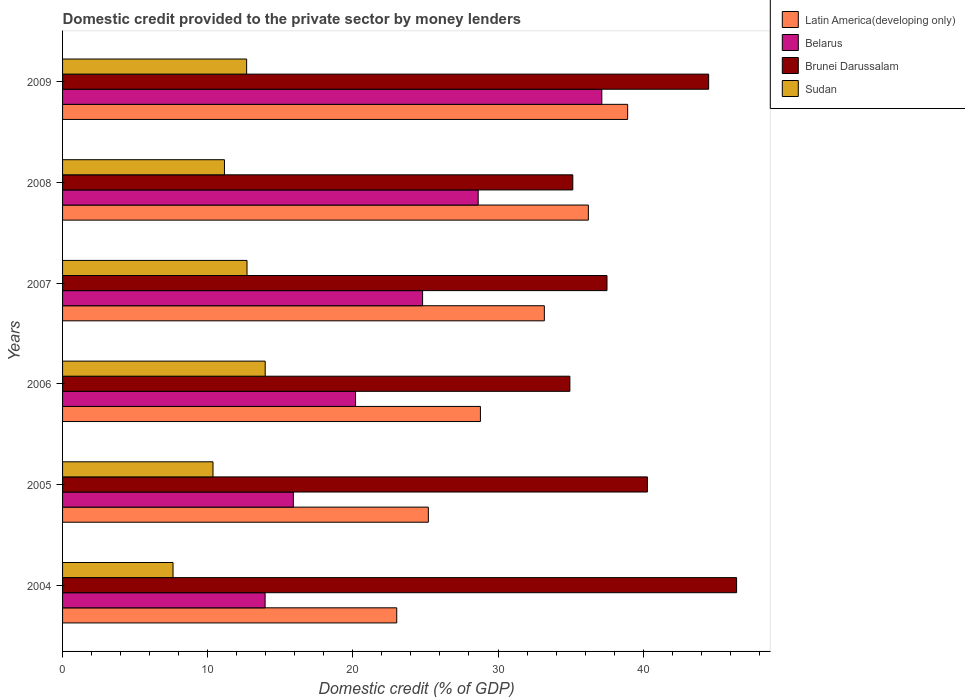Are the number of bars per tick equal to the number of legend labels?
Keep it short and to the point. Yes. What is the domestic credit provided to the private sector by money lenders in Brunei Darussalam in 2005?
Offer a very short reply. 40.29. Across all years, what is the maximum domestic credit provided to the private sector by money lenders in Belarus?
Ensure brevity in your answer.  37.15. Across all years, what is the minimum domestic credit provided to the private sector by money lenders in Belarus?
Your response must be concise. 13.95. In which year was the domestic credit provided to the private sector by money lenders in Sudan minimum?
Provide a succinct answer. 2004. What is the total domestic credit provided to the private sector by money lenders in Sudan in the graph?
Offer a terse response. 68.48. What is the difference between the domestic credit provided to the private sector by money lenders in Brunei Darussalam in 2006 and that in 2007?
Provide a succinct answer. -2.56. What is the difference between the domestic credit provided to the private sector by money lenders in Brunei Darussalam in 2005 and the domestic credit provided to the private sector by money lenders in Sudan in 2007?
Offer a terse response. 27.58. What is the average domestic credit provided to the private sector by money lenders in Latin America(developing only) per year?
Make the answer very short. 30.89. In the year 2005, what is the difference between the domestic credit provided to the private sector by money lenders in Brunei Darussalam and domestic credit provided to the private sector by money lenders in Belarus?
Give a very brief answer. 24.39. In how many years, is the domestic credit provided to the private sector by money lenders in Latin America(developing only) greater than 30 %?
Make the answer very short. 3. What is the ratio of the domestic credit provided to the private sector by money lenders in Belarus in 2004 to that in 2005?
Ensure brevity in your answer.  0.88. Is the difference between the domestic credit provided to the private sector by money lenders in Brunei Darussalam in 2006 and 2009 greater than the difference between the domestic credit provided to the private sector by money lenders in Belarus in 2006 and 2009?
Your answer should be compact. Yes. What is the difference between the highest and the second highest domestic credit provided to the private sector by money lenders in Belarus?
Keep it short and to the point. 8.52. What is the difference between the highest and the lowest domestic credit provided to the private sector by money lenders in Latin America(developing only)?
Your answer should be compact. 15.91. Is the sum of the domestic credit provided to the private sector by money lenders in Brunei Darussalam in 2004 and 2007 greater than the maximum domestic credit provided to the private sector by money lenders in Latin America(developing only) across all years?
Offer a terse response. Yes. What does the 1st bar from the top in 2009 represents?
Ensure brevity in your answer.  Sudan. What does the 2nd bar from the bottom in 2004 represents?
Your answer should be very brief. Belarus. How many bars are there?
Provide a short and direct response. 24. How many years are there in the graph?
Make the answer very short. 6. What is the difference between two consecutive major ticks on the X-axis?
Offer a very short reply. 10. Are the values on the major ticks of X-axis written in scientific E-notation?
Keep it short and to the point. No. Where does the legend appear in the graph?
Ensure brevity in your answer.  Top right. How many legend labels are there?
Ensure brevity in your answer.  4. How are the legend labels stacked?
Give a very brief answer. Vertical. What is the title of the graph?
Keep it short and to the point. Domestic credit provided to the private sector by money lenders. Does "Macao" appear as one of the legend labels in the graph?
Your answer should be compact. No. What is the label or title of the X-axis?
Offer a very short reply. Domestic credit (% of GDP). What is the Domestic credit (% of GDP) of Latin America(developing only) in 2004?
Your answer should be very brief. 23.02. What is the Domestic credit (% of GDP) of Belarus in 2004?
Keep it short and to the point. 13.95. What is the Domestic credit (% of GDP) of Brunei Darussalam in 2004?
Give a very brief answer. 46.44. What is the Domestic credit (% of GDP) in Sudan in 2004?
Provide a short and direct response. 7.61. What is the Domestic credit (% of GDP) in Latin America(developing only) in 2005?
Your response must be concise. 25.2. What is the Domestic credit (% of GDP) of Belarus in 2005?
Ensure brevity in your answer.  15.9. What is the Domestic credit (% of GDP) in Brunei Darussalam in 2005?
Ensure brevity in your answer.  40.29. What is the Domestic credit (% of GDP) of Sudan in 2005?
Offer a very short reply. 10.36. What is the Domestic credit (% of GDP) of Latin America(developing only) in 2006?
Your answer should be compact. 28.79. What is the Domestic credit (% of GDP) in Belarus in 2006?
Make the answer very short. 20.19. What is the Domestic credit (% of GDP) in Brunei Darussalam in 2006?
Offer a very short reply. 34.95. What is the Domestic credit (% of GDP) in Sudan in 2006?
Ensure brevity in your answer.  13.96. What is the Domestic credit (% of GDP) of Latin America(developing only) in 2007?
Make the answer very short. 33.19. What is the Domestic credit (% of GDP) in Belarus in 2007?
Keep it short and to the point. 24.8. What is the Domestic credit (% of GDP) in Brunei Darussalam in 2007?
Give a very brief answer. 37.51. What is the Domestic credit (% of GDP) in Sudan in 2007?
Keep it short and to the point. 12.71. What is the Domestic credit (% of GDP) in Latin America(developing only) in 2008?
Ensure brevity in your answer.  36.22. What is the Domestic credit (% of GDP) in Belarus in 2008?
Your answer should be compact. 28.63. What is the Domestic credit (% of GDP) of Brunei Darussalam in 2008?
Keep it short and to the point. 35.15. What is the Domestic credit (% of GDP) of Sudan in 2008?
Offer a very short reply. 11.15. What is the Domestic credit (% of GDP) in Latin America(developing only) in 2009?
Ensure brevity in your answer.  38.93. What is the Domestic credit (% of GDP) of Belarus in 2009?
Your answer should be very brief. 37.15. What is the Domestic credit (% of GDP) in Brunei Darussalam in 2009?
Make the answer very short. 44.51. What is the Domestic credit (% of GDP) of Sudan in 2009?
Your answer should be compact. 12.68. Across all years, what is the maximum Domestic credit (% of GDP) of Latin America(developing only)?
Your response must be concise. 38.93. Across all years, what is the maximum Domestic credit (% of GDP) of Belarus?
Your answer should be compact. 37.15. Across all years, what is the maximum Domestic credit (% of GDP) in Brunei Darussalam?
Keep it short and to the point. 46.44. Across all years, what is the maximum Domestic credit (% of GDP) of Sudan?
Your answer should be compact. 13.96. Across all years, what is the minimum Domestic credit (% of GDP) in Latin America(developing only)?
Offer a very short reply. 23.02. Across all years, what is the minimum Domestic credit (% of GDP) in Belarus?
Ensure brevity in your answer.  13.95. Across all years, what is the minimum Domestic credit (% of GDP) in Brunei Darussalam?
Provide a short and direct response. 34.95. Across all years, what is the minimum Domestic credit (% of GDP) of Sudan?
Keep it short and to the point. 7.61. What is the total Domestic credit (% of GDP) in Latin America(developing only) in the graph?
Your answer should be compact. 185.36. What is the total Domestic credit (% of GDP) of Belarus in the graph?
Provide a succinct answer. 140.63. What is the total Domestic credit (% of GDP) in Brunei Darussalam in the graph?
Offer a very short reply. 238.85. What is the total Domestic credit (% of GDP) of Sudan in the graph?
Give a very brief answer. 68.48. What is the difference between the Domestic credit (% of GDP) of Latin America(developing only) in 2004 and that in 2005?
Keep it short and to the point. -2.18. What is the difference between the Domestic credit (% of GDP) in Belarus in 2004 and that in 2005?
Offer a very short reply. -1.95. What is the difference between the Domestic credit (% of GDP) in Brunei Darussalam in 2004 and that in 2005?
Provide a succinct answer. 6.14. What is the difference between the Domestic credit (% of GDP) in Sudan in 2004 and that in 2005?
Provide a succinct answer. -2.75. What is the difference between the Domestic credit (% of GDP) of Latin America(developing only) in 2004 and that in 2006?
Give a very brief answer. -5.76. What is the difference between the Domestic credit (% of GDP) of Belarus in 2004 and that in 2006?
Give a very brief answer. -6.23. What is the difference between the Domestic credit (% of GDP) of Brunei Darussalam in 2004 and that in 2006?
Give a very brief answer. 11.49. What is the difference between the Domestic credit (% of GDP) in Sudan in 2004 and that in 2006?
Your response must be concise. -6.35. What is the difference between the Domestic credit (% of GDP) of Latin America(developing only) in 2004 and that in 2007?
Your answer should be very brief. -10.17. What is the difference between the Domestic credit (% of GDP) in Belarus in 2004 and that in 2007?
Your answer should be very brief. -10.85. What is the difference between the Domestic credit (% of GDP) in Brunei Darussalam in 2004 and that in 2007?
Ensure brevity in your answer.  8.93. What is the difference between the Domestic credit (% of GDP) of Sudan in 2004 and that in 2007?
Provide a succinct answer. -5.1. What is the difference between the Domestic credit (% of GDP) in Latin America(developing only) in 2004 and that in 2008?
Make the answer very short. -13.2. What is the difference between the Domestic credit (% of GDP) in Belarus in 2004 and that in 2008?
Offer a terse response. -14.68. What is the difference between the Domestic credit (% of GDP) in Brunei Darussalam in 2004 and that in 2008?
Make the answer very short. 11.28. What is the difference between the Domestic credit (% of GDP) in Sudan in 2004 and that in 2008?
Your answer should be compact. -3.54. What is the difference between the Domestic credit (% of GDP) in Latin America(developing only) in 2004 and that in 2009?
Keep it short and to the point. -15.91. What is the difference between the Domestic credit (% of GDP) of Belarus in 2004 and that in 2009?
Your response must be concise. -23.2. What is the difference between the Domestic credit (% of GDP) of Brunei Darussalam in 2004 and that in 2009?
Offer a very short reply. 1.92. What is the difference between the Domestic credit (% of GDP) in Sudan in 2004 and that in 2009?
Ensure brevity in your answer.  -5.07. What is the difference between the Domestic credit (% of GDP) in Latin America(developing only) in 2005 and that in 2006?
Keep it short and to the point. -3.59. What is the difference between the Domestic credit (% of GDP) in Belarus in 2005 and that in 2006?
Your answer should be compact. -4.29. What is the difference between the Domestic credit (% of GDP) of Brunei Darussalam in 2005 and that in 2006?
Offer a very short reply. 5.34. What is the difference between the Domestic credit (% of GDP) in Sudan in 2005 and that in 2006?
Your response must be concise. -3.6. What is the difference between the Domestic credit (% of GDP) in Latin America(developing only) in 2005 and that in 2007?
Provide a short and direct response. -7.99. What is the difference between the Domestic credit (% of GDP) of Belarus in 2005 and that in 2007?
Your answer should be compact. -8.91. What is the difference between the Domestic credit (% of GDP) in Brunei Darussalam in 2005 and that in 2007?
Keep it short and to the point. 2.78. What is the difference between the Domestic credit (% of GDP) of Sudan in 2005 and that in 2007?
Ensure brevity in your answer.  -2.34. What is the difference between the Domestic credit (% of GDP) in Latin America(developing only) in 2005 and that in 2008?
Offer a terse response. -11.02. What is the difference between the Domestic credit (% of GDP) of Belarus in 2005 and that in 2008?
Provide a short and direct response. -12.74. What is the difference between the Domestic credit (% of GDP) of Brunei Darussalam in 2005 and that in 2008?
Ensure brevity in your answer.  5.14. What is the difference between the Domestic credit (% of GDP) in Sudan in 2005 and that in 2008?
Your answer should be compact. -0.79. What is the difference between the Domestic credit (% of GDP) of Latin America(developing only) in 2005 and that in 2009?
Provide a short and direct response. -13.73. What is the difference between the Domestic credit (% of GDP) in Belarus in 2005 and that in 2009?
Make the answer very short. -21.25. What is the difference between the Domestic credit (% of GDP) of Brunei Darussalam in 2005 and that in 2009?
Offer a terse response. -4.22. What is the difference between the Domestic credit (% of GDP) of Sudan in 2005 and that in 2009?
Give a very brief answer. -2.32. What is the difference between the Domestic credit (% of GDP) of Latin America(developing only) in 2006 and that in 2007?
Offer a very short reply. -4.4. What is the difference between the Domestic credit (% of GDP) of Belarus in 2006 and that in 2007?
Make the answer very short. -4.62. What is the difference between the Domestic credit (% of GDP) of Brunei Darussalam in 2006 and that in 2007?
Provide a succinct answer. -2.56. What is the difference between the Domestic credit (% of GDP) of Sudan in 2006 and that in 2007?
Ensure brevity in your answer.  1.25. What is the difference between the Domestic credit (% of GDP) in Latin America(developing only) in 2006 and that in 2008?
Make the answer very short. -7.44. What is the difference between the Domestic credit (% of GDP) in Belarus in 2006 and that in 2008?
Keep it short and to the point. -8.45. What is the difference between the Domestic credit (% of GDP) of Brunei Darussalam in 2006 and that in 2008?
Your response must be concise. -0.2. What is the difference between the Domestic credit (% of GDP) in Sudan in 2006 and that in 2008?
Keep it short and to the point. 2.81. What is the difference between the Domestic credit (% of GDP) in Latin America(developing only) in 2006 and that in 2009?
Your response must be concise. -10.14. What is the difference between the Domestic credit (% of GDP) in Belarus in 2006 and that in 2009?
Offer a very short reply. -16.97. What is the difference between the Domestic credit (% of GDP) in Brunei Darussalam in 2006 and that in 2009?
Make the answer very short. -9.56. What is the difference between the Domestic credit (% of GDP) in Sudan in 2006 and that in 2009?
Ensure brevity in your answer.  1.28. What is the difference between the Domestic credit (% of GDP) in Latin America(developing only) in 2007 and that in 2008?
Your answer should be very brief. -3.03. What is the difference between the Domestic credit (% of GDP) of Belarus in 2007 and that in 2008?
Keep it short and to the point. -3.83. What is the difference between the Domestic credit (% of GDP) in Brunei Darussalam in 2007 and that in 2008?
Offer a terse response. 2.36. What is the difference between the Domestic credit (% of GDP) of Sudan in 2007 and that in 2008?
Offer a very short reply. 1.56. What is the difference between the Domestic credit (% of GDP) in Latin America(developing only) in 2007 and that in 2009?
Make the answer very short. -5.74. What is the difference between the Domestic credit (% of GDP) in Belarus in 2007 and that in 2009?
Provide a short and direct response. -12.35. What is the difference between the Domestic credit (% of GDP) of Brunei Darussalam in 2007 and that in 2009?
Your answer should be compact. -7. What is the difference between the Domestic credit (% of GDP) of Sudan in 2007 and that in 2009?
Offer a very short reply. 0.03. What is the difference between the Domestic credit (% of GDP) of Latin America(developing only) in 2008 and that in 2009?
Your answer should be compact. -2.71. What is the difference between the Domestic credit (% of GDP) in Belarus in 2008 and that in 2009?
Keep it short and to the point. -8.52. What is the difference between the Domestic credit (% of GDP) of Brunei Darussalam in 2008 and that in 2009?
Make the answer very short. -9.36. What is the difference between the Domestic credit (% of GDP) in Sudan in 2008 and that in 2009?
Your answer should be compact. -1.53. What is the difference between the Domestic credit (% of GDP) of Latin America(developing only) in 2004 and the Domestic credit (% of GDP) of Belarus in 2005?
Ensure brevity in your answer.  7.12. What is the difference between the Domestic credit (% of GDP) in Latin America(developing only) in 2004 and the Domestic credit (% of GDP) in Brunei Darussalam in 2005?
Provide a succinct answer. -17.27. What is the difference between the Domestic credit (% of GDP) in Latin America(developing only) in 2004 and the Domestic credit (% of GDP) in Sudan in 2005?
Make the answer very short. 12.66. What is the difference between the Domestic credit (% of GDP) of Belarus in 2004 and the Domestic credit (% of GDP) of Brunei Darussalam in 2005?
Keep it short and to the point. -26.34. What is the difference between the Domestic credit (% of GDP) in Belarus in 2004 and the Domestic credit (% of GDP) in Sudan in 2005?
Give a very brief answer. 3.59. What is the difference between the Domestic credit (% of GDP) of Brunei Darussalam in 2004 and the Domestic credit (% of GDP) of Sudan in 2005?
Keep it short and to the point. 36.07. What is the difference between the Domestic credit (% of GDP) in Latin America(developing only) in 2004 and the Domestic credit (% of GDP) in Belarus in 2006?
Your answer should be compact. 2.84. What is the difference between the Domestic credit (% of GDP) of Latin America(developing only) in 2004 and the Domestic credit (% of GDP) of Brunei Darussalam in 2006?
Your answer should be very brief. -11.93. What is the difference between the Domestic credit (% of GDP) of Latin America(developing only) in 2004 and the Domestic credit (% of GDP) of Sudan in 2006?
Keep it short and to the point. 9.06. What is the difference between the Domestic credit (% of GDP) in Belarus in 2004 and the Domestic credit (% of GDP) in Brunei Darussalam in 2006?
Your answer should be very brief. -21. What is the difference between the Domestic credit (% of GDP) in Belarus in 2004 and the Domestic credit (% of GDP) in Sudan in 2006?
Your response must be concise. -0.01. What is the difference between the Domestic credit (% of GDP) of Brunei Darussalam in 2004 and the Domestic credit (% of GDP) of Sudan in 2006?
Your answer should be very brief. 32.48. What is the difference between the Domestic credit (% of GDP) of Latin America(developing only) in 2004 and the Domestic credit (% of GDP) of Belarus in 2007?
Give a very brief answer. -1.78. What is the difference between the Domestic credit (% of GDP) of Latin America(developing only) in 2004 and the Domestic credit (% of GDP) of Brunei Darussalam in 2007?
Offer a very short reply. -14.48. What is the difference between the Domestic credit (% of GDP) of Latin America(developing only) in 2004 and the Domestic credit (% of GDP) of Sudan in 2007?
Keep it short and to the point. 10.32. What is the difference between the Domestic credit (% of GDP) of Belarus in 2004 and the Domestic credit (% of GDP) of Brunei Darussalam in 2007?
Offer a very short reply. -23.55. What is the difference between the Domestic credit (% of GDP) in Belarus in 2004 and the Domestic credit (% of GDP) in Sudan in 2007?
Ensure brevity in your answer.  1.25. What is the difference between the Domestic credit (% of GDP) in Brunei Darussalam in 2004 and the Domestic credit (% of GDP) in Sudan in 2007?
Offer a terse response. 33.73. What is the difference between the Domestic credit (% of GDP) in Latin America(developing only) in 2004 and the Domestic credit (% of GDP) in Belarus in 2008?
Keep it short and to the point. -5.61. What is the difference between the Domestic credit (% of GDP) of Latin America(developing only) in 2004 and the Domestic credit (% of GDP) of Brunei Darussalam in 2008?
Offer a very short reply. -12.13. What is the difference between the Domestic credit (% of GDP) of Latin America(developing only) in 2004 and the Domestic credit (% of GDP) of Sudan in 2008?
Give a very brief answer. 11.87. What is the difference between the Domestic credit (% of GDP) in Belarus in 2004 and the Domestic credit (% of GDP) in Brunei Darussalam in 2008?
Ensure brevity in your answer.  -21.2. What is the difference between the Domestic credit (% of GDP) of Belarus in 2004 and the Domestic credit (% of GDP) of Sudan in 2008?
Ensure brevity in your answer.  2.8. What is the difference between the Domestic credit (% of GDP) of Brunei Darussalam in 2004 and the Domestic credit (% of GDP) of Sudan in 2008?
Offer a terse response. 35.28. What is the difference between the Domestic credit (% of GDP) of Latin America(developing only) in 2004 and the Domestic credit (% of GDP) of Belarus in 2009?
Your answer should be very brief. -14.13. What is the difference between the Domestic credit (% of GDP) in Latin America(developing only) in 2004 and the Domestic credit (% of GDP) in Brunei Darussalam in 2009?
Provide a succinct answer. -21.49. What is the difference between the Domestic credit (% of GDP) of Latin America(developing only) in 2004 and the Domestic credit (% of GDP) of Sudan in 2009?
Your answer should be compact. 10.34. What is the difference between the Domestic credit (% of GDP) in Belarus in 2004 and the Domestic credit (% of GDP) in Brunei Darussalam in 2009?
Offer a terse response. -30.56. What is the difference between the Domestic credit (% of GDP) of Belarus in 2004 and the Domestic credit (% of GDP) of Sudan in 2009?
Provide a short and direct response. 1.27. What is the difference between the Domestic credit (% of GDP) of Brunei Darussalam in 2004 and the Domestic credit (% of GDP) of Sudan in 2009?
Ensure brevity in your answer.  33.75. What is the difference between the Domestic credit (% of GDP) in Latin America(developing only) in 2005 and the Domestic credit (% of GDP) in Belarus in 2006?
Offer a very short reply. 5.01. What is the difference between the Domestic credit (% of GDP) of Latin America(developing only) in 2005 and the Domestic credit (% of GDP) of Brunei Darussalam in 2006?
Ensure brevity in your answer.  -9.75. What is the difference between the Domestic credit (% of GDP) in Latin America(developing only) in 2005 and the Domestic credit (% of GDP) in Sudan in 2006?
Your answer should be compact. 11.24. What is the difference between the Domestic credit (% of GDP) of Belarus in 2005 and the Domestic credit (% of GDP) of Brunei Darussalam in 2006?
Make the answer very short. -19.05. What is the difference between the Domestic credit (% of GDP) in Belarus in 2005 and the Domestic credit (% of GDP) in Sudan in 2006?
Provide a short and direct response. 1.94. What is the difference between the Domestic credit (% of GDP) of Brunei Darussalam in 2005 and the Domestic credit (% of GDP) of Sudan in 2006?
Offer a terse response. 26.33. What is the difference between the Domestic credit (% of GDP) in Latin America(developing only) in 2005 and the Domestic credit (% of GDP) in Belarus in 2007?
Make the answer very short. 0.4. What is the difference between the Domestic credit (% of GDP) of Latin America(developing only) in 2005 and the Domestic credit (% of GDP) of Brunei Darussalam in 2007?
Give a very brief answer. -12.31. What is the difference between the Domestic credit (% of GDP) in Latin America(developing only) in 2005 and the Domestic credit (% of GDP) in Sudan in 2007?
Your response must be concise. 12.49. What is the difference between the Domestic credit (% of GDP) in Belarus in 2005 and the Domestic credit (% of GDP) in Brunei Darussalam in 2007?
Keep it short and to the point. -21.61. What is the difference between the Domestic credit (% of GDP) in Belarus in 2005 and the Domestic credit (% of GDP) in Sudan in 2007?
Ensure brevity in your answer.  3.19. What is the difference between the Domestic credit (% of GDP) in Brunei Darussalam in 2005 and the Domestic credit (% of GDP) in Sudan in 2007?
Your response must be concise. 27.58. What is the difference between the Domestic credit (% of GDP) of Latin America(developing only) in 2005 and the Domestic credit (% of GDP) of Belarus in 2008?
Provide a succinct answer. -3.43. What is the difference between the Domestic credit (% of GDP) of Latin America(developing only) in 2005 and the Domestic credit (% of GDP) of Brunei Darussalam in 2008?
Your answer should be very brief. -9.95. What is the difference between the Domestic credit (% of GDP) of Latin America(developing only) in 2005 and the Domestic credit (% of GDP) of Sudan in 2008?
Offer a terse response. 14.05. What is the difference between the Domestic credit (% of GDP) in Belarus in 2005 and the Domestic credit (% of GDP) in Brunei Darussalam in 2008?
Give a very brief answer. -19.25. What is the difference between the Domestic credit (% of GDP) of Belarus in 2005 and the Domestic credit (% of GDP) of Sudan in 2008?
Provide a succinct answer. 4.75. What is the difference between the Domestic credit (% of GDP) in Brunei Darussalam in 2005 and the Domestic credit (% of GDP) in Sudan in 2008?
Your answer should be compact. 29.14. What is the difference between the Domestic credit (% of GDP) in Latin America(developing only) in 2005 and the Domestic credit (% of GDP) in Belarus in 2009?
Give a very brief answer. -11.95. What is the difference between the Domestic credit (% of GDP) of Latin America(developing only) in 2005 and the Domestic credit (% of GDP) of Brunei Darussalam in 2009?
Your response must be concise. -19.31. What is the difference between the Domestic credit (% of GDP) in Latin America(developing only) in 2005 and the Domestic credit (% of GDP) in Sudan in 2009?
Give a very brief answer. 12.52. What is the difference between the Domestic credit (% of GDP) in Belarus in 2005 and the Domestic credit (% of GDP) in Brunei Darussalam in 2009?
Keep it short and to the point. -28.61. What is the difference between the Domestic credit (% of GDP) of Belarus in 2005 and the Domestic credit (% of GDP) of Sudan in 2009?
Keep it short and to the point. 3.22. What is the difference between the Domestic credit (% of GDP) of Brunei Darussalam in 2005 and the Domestic credit (% of GDP) of Sudan in 2009?
Provide a succinct answer. 27.61. What is the difference between the Domestic credit (% of GDP) in Latin America(developing only) in 2006 and the Domestic credit (% of GDP) in Belarus in 2007?
Provide a short and direct response. 3.98. What is the difference between the Domestic credit (% of GDP) in Latin America(developing only) in 2006 and the Domestic credit (% of GDP) in Brunei Darussalam in 2007?
Ensure brevity in your answer.  -8.72. What is the difference between the Domestic credit (% of GDP) of Latin America(developing only) in 2006 and the Domestic credit (% of GDP) of Sudan in 2007?
Provide a succinct answer. 16.08. What is the difference between the Domestic credit (% of GDP) in Belarus in 2006 and the Domestic credit (% of GDP) in Brunei Darussalam in 2007?
Give a very brief answer. -17.32. What is the difference between the Domestic credit (% of GDP) of Belarus in 2006 and the Domestic credit (% of GDP) of Sudan in 2007?
Provide a succinct answer. 7.48. What is the difference between the Domestic credit (% of GDP) of Brunei Darussalam in 2006 and the Domestic credit (% of GDP) of Sudan in 2007?
Keep it short and to the point. 22.24. What is the difference between the Domestic credit (% of GDP) of Latin America(developing only) in 2006 and the Domestic credit (% of GDP) of Belarus in 2008?
Provide a succinct answer. 0.15. What is the difference between the Domestic credit (% of GDP) in Latin America(developing only) in 2006 and the Domestic credit (% of GDP) in Brunei Darussalam in 2008?
Offer a terse response. -6.36. What is the difference between the Domestic credit (% of GDP) in Latin America(developing only) in 2006 and the Domestic credit (% of GDP) in Sudan in 2008?
Ensure brevity in your answer.  17.64. What is the difference between the Domestic credit (% of GDP) of Belarus in 2006 and the Domestic credit (% of GDP) of Brunei Darussalam in 2008?
Give a very brief answer. -14.97. What is the difference between the Domestic credit (% of GDP) of Belarus in 2006 and the Domestic credit (% of GDP) of Sudan in 2008?
Make the answer very short. 9.03. What is the difference between the Domestic credit (% of GDP) of Brunei Darussalam in 2006 and the Domestic credit (% of GDP) of Sudan in 2008?
Give a very brief answer. 23.8. What is the difference between the Domestic credit (% of GDP) of Latin America(developing only) in 2006 and the Domestic credit (% of GDP) of Belarus in 2009?
Offer a very short reply. -8.36. What is the difference between the Domestic credit (% of GDP) of Latin America(developing only) in 2006 and the Domestic credit (% of GDP) of Brunei Darussalam in 2009?
Your response must be concise. -15.72. What is the difference between the Domestic credit (% of GDP) in Latin America(developing only) in 2006 and the Domestic credit (% of GDP) in Sudan in 2009?
Offer a terse response. 16.11. What is the difference between the Domestic credit (% of GDP) in Belarus in 2006 and the Domestic credit (% of GDP) in Brunei Darussalam in 2009?
Your response must be concise. -24.33. What is the difference between the Domestic credit (% of GDP) of Belarus in 2006 and the Domestic credit (% of GDP) of Sudan in 2009?
Ensure brevity in your answer.  7.5. What is the difference between the Domestic credit (% of GDP) in Brunei Darussalam in 2006 and the Domestic credit (% of GDP) in Sudan in 2009?
Your answer should be very brief. 22.27. What is the difference between the Domestic credit (% of GDP) in Latin America(developing only) in 2007 and the Domestic credit (% of GDP) in Belarus in 2008?
Your response must be concise. 4.56. What is the difference between the Domestic credit (% of GDP) of Latin America(developing only) in 2007 and the Domestic credit (% of GDP) of Brunei Darussalam in 2008?
Give a very brief answer. -1.96. What is the difference between the Domestic credit (% of GDP) of Latin America(developing only) in 2007 and the Domestic credit (% of GDP) of Sudan in 2008?
Give a very brief answer. 22.04. What is the difference between the Domestic credit (% of GDP) of Belarus in 2007 and the Domestic credit (% of GDP) of Brunei Darussalam in 2008?
Offer a very short reply. -10.35. What is the difference between the Domestic credit (% of GDP) of Belarus in 2007 and the Domestic credit (% of GDP) of Sudan in 2008?
Offer a terse response. 13.65. What is the difference between the Domestic credit (% of GDP) in Brunei Darussalam in 2007 and the Domestic credit (% of GDP) in Sudan in 2008?
Give a very brief answer. 26.36. What is the difference between the Domestic credit (% of GDP) in Latin America(developing only) in 2007 and the Domestic credit (% of GDP) in Belarus in 2009?
Your answer should be compact. -3.96. What is the difference between the Domestic credit (% of GDP) in Latin America(developing only) in 2007 and the Domestic credit (% of GDP) in Brunei Darussalam in 2009?
Ensure brevity in your answer.  -11.32. What is the difference between the Domestic credit (% of GDP) in Latin America(developing only) in 2007 and the Domestic credit (% of GDP) in Sudan in 2009?
Offer a very short reply. 20.51. What is the difference between the Domestic credit (% of GDP) of Belarus in 2007 and the Domestic credit (% of GDP) of Brunei Darussalam in 2009?
Keep it short and to the point. -19.71. What is the difference between the Domestic credit (% of GDP) of Belarus in 2007 and the Domestic credit (% of GDP) of Sudan in 2009?
Provide a short and direct response. 12.12. What is the difference between the Domestic credit (% of GDP) of Brunei Darussalam in 2007 and the Domestic credit (% of GDP) of Sudan in 2009?
Provide a short and direct response. 24.83. What is the difference between the Domestic credit (% of GDP) of Latin America(developing only) in 2008 and the Domestic credit (% of GDP) of Belarus in 2009?
Provide a short and direct response. -0.93. What is the difference between the Domestic credit (% of GDP) in Latin America(developing only) in 2008 and the Domestic credit (% of GDP) in Brunei Darussalam in 2009?
Your response must be concise. -8.29. What is the difference between the Domestic credit (% of GDP) of Latin America(developing only) in 2008 and the Domestic credit (% of GDP) of Sudan in 2009?
Ensure brevity in your answer.  23.54. What is the difference between the Domestic credit (% of GDP) of Belarus in 2008 and the Domestic credit (% of GDP) of Brunei Darussalam in 2009?
Ensure brevity in your answer.  -15.88. What is the difference between the Domestic credit (% of GDP) of Belarus in 2008 and the Domestic credit (% of GDP) of Sudan in 2009?
Your answer should be compact. 15.95. What is the difference between the Domestic credit (% of GDP) in Brunei Darussalam in 2008 and the Domestic credit (% of GDP) in Sudan in 2009?
Provide a succinct answer. 22.47. What is the average Domestic credit (% of GDP) of Latin America(developing only) per year?
Your answer should be very brief. 30.89. What is the average Domestic credit (% of GDP) in Belarus per year?
Keep it short and to the point. 23.44. What is the average Domestic credit (% of GDP) in Brunei Darussalam per year?
Offer a terse response. 39.81. What is the average Domestic credit (% of GDP) of Sudan per year?
Offer a terse response. 11.41. In the year 2004, what is the difference between the Domestic credit (% of GDP) of Latin America(developing only) and Domestic credit (% of GDP) of Belarus?
Offer a terse response. 9.07. In the year 2004, what is the difference between the Domestic credit (% of GDP) in Latin America(developing only) and Domestic credit (% of GDP) in Brunei Darussalam?
Make the answer very short. -23.41. In the year 2004, what is the difference between the Domestic credit (% of GDP) of Latin America(developing only) and Domestic credit (% of GDP) of Sudan?
Your answer should be compact. 15.41. In the year 2004, what is the difference between the Domestic credit (% of GDP) of Belarus and Domestic credit (% of GDP) of Brunei Darussalam?
Offer a terse response. -32.48. In the year 2004, what is the difference between the Domestic credit (% of GDP) in Belarus and Domestic credit (% of GDP) in Sudan?
Make the answer very short. 6.34. In the year 2004, what is the difference between the Domestic credit (% of GDP) in Brunei Darussalam and Domestic credit (% of GDP) in Sudan?
Provide a short and direct response. 38.83. In the year 2005, what is the difference between the Domestic credit (% of GDP) of Latin America(developing only) and Domestic credit (% of GDP) of Belarus?
Offer a terse response. 9.3. In the year 2005, what is the difference between the Domestic credit (% of GDP) of Latin America(developing only) and Domestic credit (% of GDP) of Brunei Darussalam?
Offer a very short reply. -15.09. In the year 2005, what is the difference between the Domestic credit (% of GDP) in Latin America(developing only) and Domestic credit (% of GDP) in Sudan?
Ensure brevity in your answer.  14.84. In the year 2005, what is the difference between the Domestic credit (% of GDP) of Belarus and Domestic credit (% of GDP) of Brunei Darussalam?
Give a very brief answer. -24.39. In the year 2005, what is the difference between the Domestic credit (% of GDP) in Belarus and Domestic credit (% of GDP) in Sudan?
Make the answer very short. 5.53. In the year 2005, what is the difference between the Domestic credit (% of GDP) of Brunei Darussalam and Domestic credit (% of GDP) of Sudan?
Your answer should be compact. 29.93. In the year 2006, what is the difference between the Domestic credit (% of GDP) of Latin America(developing only) and Domestic credit (% of GDP) of Belarus?
Offer a terse response. 8.6. In the year 2006, what is the difference between the Domestic credit (% of GDP) of Latin America(developing only) and Domestic credit (% of GDP) of Brunei Darussalam?
Your response must be concise. -6.16. In the year 2006, what is the difference between the Domestic credit (% of GDP) of Latin America(developing only) and Domestic credit (% of GDP) of Sudan?
Make the answer very short. 14.83. In the year 2006, what is the difference between the Domestic credit (% of GDP) of Belarus and Domestic credit (% of GDP) of Brunei Darussalam?
Give a very brief answer. -14.76. In the year 2006, what is the difference between the Domestic credit (% of GDP) in Belarus and Domestic credit (% of GDP) in Sudan?
Keep it short and to the point. 6.22. In the year 2006, what is the difference between the Domestic credit (% of GDP) of Brunei Darussalam and Domestic credit (% of GDP) of Sudan?
Offer a very short reply. 20.99. In the year 2007, what is the difference between the Domestic credit (% of GDP) of Latin America(developing only) and Domestic credit (% of GDP) of Belarus?
Keep it short and to the point. 8.39. In the year 2007, what is the difference between the Domestic credit (% of GDP) of Latin America(developing only) and Domestic credit (% of GDP) of Brunei Darussalam?
Offer a terse response. -4.32. In the year 2007, what is the difference between the Domestic credit (% of GDP) in Latin America(developing only) and Domestic credit (% of GDP) in Sudan?
Offer a terse response. 20.48. In the year 2007, what is the difference between the Domestic credit (% of GDP) of Belarus and Domestic credit (% of GDP) of Brunei Darussalam?
Offer a very short reply. -12.7. In the year 2007, what is the difference between the Domestic credit (% of GDP) in Belarus and Domestic credit (% of GDP) in Sudan?
Your answer should be compact. 12.1. In the year 2007, what is the difference between the Domestic credit (% of GDP) in Brunei Darussalam and Domestic credit (% of GDP) in Sudan?
Your response must be concise. 24.8. In the year 2008, what is the difference between the Domestic credit (% of GDP) of Latin America(developing only) and Domestic credit (% of GDP) of Belarus?
Offer a very short reply. 7.59. In the year 2008, what is the difference between the Domestic credit (% of GDP) of Latin America(developing only) and Domestic credit (% of GDP) of Brunei Darussalam?
Ensure brevity in your answer.  1.07. In the year 2008, what is the difference between the Domestic credit (% of GDP) in Latin America(developing only) and Domestic credit (% of GDP) in Sudan?
Provide a short and direct response. 25.07. In the year 2008, what is the difference between the Domestic credit (% of GDP) in Belarus and Domestic credit (% of GDP) in Brunei Darussalam?
Give a very brief answer. -6.52. In the year 2008, what is the difference between the Domestic credit (% of GDP) of Belarus and Domestic credit (% of GDP) of Sudan?
Give a very brief answer. 17.48. In the year 2008, what is the difference between the Domestic credit (% of GDP) of Brunei Darussalam and Domestic credit (% of GDP) of Sudan?
Offer a very short reply. 24. In the year 2009, what is the difference between the Domestic credit (% of GDP) of Latin America(developing only) and Domestic credit (% of GDP) of Belarus?
Your response must be concise. 1.78. In the year 2009, what is the difference between the Domestic credit (% of GDP) of Latin America(developing only) and Domestic credit (% of GDP) of Brunei Darussalam?
Provide a short and direct response. -5.58. In the year 2009, what is the difference between the Domestic credit (% of GDP) of Latin America(developing only) and Domestic credit (% of GDP) of Sudan?
Make the answer very short. 26.25. In the year 2009, what is the difference between the Domestic credit (% of GDP) of Belarus and Domestic credit (% of GDP) of Brunei Darussalam?
Provide a succinct answer. -7.36. In the year 2009, what is the difference between the Domestic credit (% of GDP) in Belarus and Domestic credit (% of GDP) in Sudan?
Your answer should be compact. 24.47. In the year 2009, what is the difference between the Domestic credit (% of GDP) in Brunei Darussalam and Domestic credit (% of GDP) in Sudan?
Ensure brevity in your answer.  31.83. What is the ratio of the Domestic credit (% of GDP) in Latin America(developing only) in 2004 to that in 2005?
Give a very brief answer. 0.91. What is the ratio of the Domestic credit (% of GDP) in Belarus in 2004 to that in 2005?
Provide a short and direct response. 0.88. What is the ratio of the Domestic credit (% of GDP) of Brunei Darussalam in 2004 to that in 2005?
Your answer should be very brief. 1.15. What is the ratio of the Domestic credit (% of GDP) in Sudan in 2004 to that in 2005?
Provide a succinct answer. 0.73. What is the ratio of the Domestic credit (% of GDP) of Latin America(developing only) in 2004 to that in 2006?
Keep it short and to the point. 0.8. What is the ratio of the Domestic credit (% of GDP) of Belarus in 2004 to that in 2006?
Your answer should be very brief. 0.69. What is the ratio of the Domestic credit (% of GDP) in Brunei Darussalam in 2004 to that in 2006?
Ensure brevity in your answer.  1.33. What is the ratio of the Domestic credit (% of GDP) of Sudan in 2004 to that in 2006?
Give a very brief answer. 0.55. What is the ratio of the Domestic credit (% of GDP) in Latin America(developing only) in 2004 to that in 2007?
Ensure brevity in your answer.  0.69. What is the ratio of the Domestic credit (% of GDP) in Belarus in 2004 to that in 2007?
Give a very brief answer. 0.56. What is the ratio of the Domestic credit (% of GDP) in Brunei Darussalam in 2004 to that in 2007?
Offer a terse response. 1.24. What is the ratio of the Domestic credit (% of GDP) in Sudan in 2004 to that in 2007?
Make the answer very short. 0.6. What is the ratio of the Domestic credit (% of GDP) of Latin America(developing only) in 2004 to that in 2008?
Offer a very short reply. 0.64. What is the ratio of the Domestic credit (% of GDP) of Belarus in 2004 to that in 2008?
Ensure brevity in your answer.  0.49. What is the ratio of the Domestic credit (% of GDP) of Brunei Darussalam in 2004 to that in 2008?
Your answer should be compact. 1.32. What is the ratio of the Domestic credit (% of GDP) in Sudan in 2004 to that in 2008?
Your response must be concise. 0.68. What is the ratio of the Domestic credit (% of GDP) of Latin America(developing only) in 2004 to that in 2009?
Ensure brevity in your answer.  0.59. What is the ratio of the Domestic credit (% of GDP) of Belarus in 2004 to that in 2009?
Provide a succinct answer. 0.38. What is the ratio of the Domestic credit (% of GDP) in Brunei Darussalam in 2004 to that in 2009?
Give a very brief answer. 1.04. What is the ratio of the Domestic credit (% of GDP) in Sudan in 2004 to that in 2009?
Ensure brevity in your answer.  0.6. What is the ratio of the Domestic credit (% of GDP) of Latin America(developing only) in 2005 to that in 2006?
Offer a very short reply. 0.88. What is the ratio of the Domestic credit (% of GDP) in Belarus in 2005 to that in 2006?
Keep it short and to the point. 0.79. What is the ratio of the Domestic credit (% of GDP) in Brunei Darussalam in 2005 to that in 2006?
Provide a succinct answer. 1.15. What is the ratio of the Domestic credit (% of GDP) of Sudan in 2005 to that in 2006?
Provide a short and direct response. 0.74. What is the ratio of the Domestic credit (% of GDP) in Latin America(developing only) in 2005 to that in 2007?
Give a very brief answer. 0.76. What is the ratio of the Domestic credit (% of GDP) of Belarus in 2005 to that in 2007?
Provide a short and direct response. 0.64. What is the ratio of the Domestic credit (% of GDP) of Brunei Darussalam in 2005 to that in 2007?
Make the answer very short. 1.07. What is the ratio of the Domestic credit (% of GDP) in Sudan in 2005 to that in 2007?
Provide a succinct answer. 0.82. What is the ratio of the Domestic credit (% of GDP) of Latin America(developing only) in 2005 to that in 2008?
Provide a succinct answer. 0.7. What is the ratio of the Domestic credit (% of GDP) in Belarus in 2005 to that in 2008?
Ensure brevity in your answer.  0.56. What is the ratio of the Domestic credit (% of GDP) of Brunei Darussalam in 2005 to that in 2008?
Make the answer very short. 1.15. What is the ratio of the Domestic credit (% of GDP) in Sudan in 2005 to that in 2008?
Your response must be concise. 0.93. What is the ratio of the Domestic credit (% of GDP) of Latin America(developing only) in 2005 to that in 2009?
Your answer should be compact. 0.65. What is the ratio of the Domestic credit (% of GDP) of Belarus in 2005 to that in 2009?
Your answer should be very brief. 0.43. What is the ratio of the Domestic credit (% of GDP) of Brunei Darussalam in 2005 to that in 2009?
Provide a succinct answer. 0.91. What is the ratio of the Domestic credit (% of GDP) in Sudan in 2005 to that in 2009?
Provide a succinct answer. 0.82. What is the ratio of the Domestic credit (% of GDP) in Latin America(developing only) in 2006 to that in 2007?
Offer a very short reply. 0.87. What is the ratio of the Domestic credit (% of GDP) in Belarus in 2006 to that in 2007?
Provide a succinct answer. 0.81. What is the ratio of the Domestic credit (% of GDP) of Brunei Darussalam in 2006 to that in 2007?
Your response must be concise. 0.93. What is the ratio of the Domestic credit (% of GDP) of Sudan in 2006 to that in 2007?
Offer a very short reply. 1.1. What is the ratio of the Domestic credit (% of GDP) of Latin America(developing only) in 2006 to that in 2008?
Provide a succinct answer. 0.79. What is the ratio of the Domestic credit (% of GDP) of Belarus in 2006 to that in 2008?
Offer a terse response. 0.7. What is the ratio of the Domestic credit (% of GDP) in Sudan in 2006 to that in 2008?
Give a very brief answer. 1.25. What is the ratio of the Domestic credit (% of GDP) in Latin America(developing only) in 2006 to that in 2009?
Keep it short and to the point. 0.74. What is the ratio of the Domestic credit (% of GDP) in Belarus in 2006 to that in 2009?
Offer a terse response. 0.54. What is the ratio of the Domestic credit (% of GDP) of Brunei Darussalam in 2006 to that in 2009?
Your answer should be very brief. 0.79. What is the ratio of the Domestic credit (% of GDP) in Sudan in 2006 to that in 2009?
Offer a terse response. 1.1. What is the ratio of the Domestic credit (% of GDP) in Latin America(developing only) in 2007 to that in 2008?
Give a very brief answer. 0.92. What is the ratio of the Domestic credit (% of GDP) of Belarus in 2007 to that in 2008?
Keep it short and to the point. 0.87. What is the ratio of the Domestic credit (% of GDP) of Brunei Darussalam in 2007 to that in 2008?
Give a very brief answer. 1.07. What is the ratio of the Domestic credit (% of GDP) of Sudan in 2007 to that in 2008?
Give a very brief answer. 1.14. What is the ratio of the Domestic credit (% of GDP) in Latin America(developing only) in 2007 to that in 2009?
Your answer should be very brief. 0.85. What is the ratio of the Domestic credit (% of GDP) of Belarus in 2007 to that in 2009?
Your response must be concise. 0.67. What is the ratio of the Domestic credit (% of GDP) of Brunei Darussalam in 2007 to that in 2009?
Provide a succinct answer. 0.84. What is the ratio of the Domestic credit (% of GDP) in Latin America(developing only) in 2008 to that in 2009?
Ensure brevity in your answer.  0.93. What is the ratio of the Domestic credit (% of GDP) in Belarus in 2008 to that in 2009?
Your answer should be compact. 0.77. What is the ratio of the Domestic credit (% of GDP) in Brunei Darussalam in 2008 to that in 2009?
Your answer should be very brief. 0.79. What is the ratio of the Domestic credit (% of GDP) of Sudan in 2008 to that in 2009?
Offer a very short reply. 0.88. What is the difference between the highest and the second highest Domestic credit (% of GDP) of Latin America(developing only)?
Keep it short and to the point. 2.71. What is the difference between the highest and the second highest Domestic credit (% of GDP) of Belarus?
Make the answer very short. 8.52. What is the difference between the highest and the second highest Domestic credit (% of GDP) in Brunei Darussalam?
Give a very brief answer. 1.92. What is the difference between the highest and the second highest Domestic credit (% of GDP) of Sudan?
Your answer should be very brief. 1.25. What is the difference between the highest and the lowest Domestic credit (% of GDP) in Latin America(developing only)?
Ensure brevity in your answer.  15.91. What is the difference between the highest and the lowest Domestic credit (% of GDP) of Belarus?
Your answer should be compact. 23.2. What is the difference between the highest and the lowest Domestic credit (% of GDP) of Brunei Darussalam?
Your answer should be very brief. 11.49. What is the difference between the highest and the lowest Domestic credit (% of GDP) in Sudan?
Offer a terse response. 6.35. 